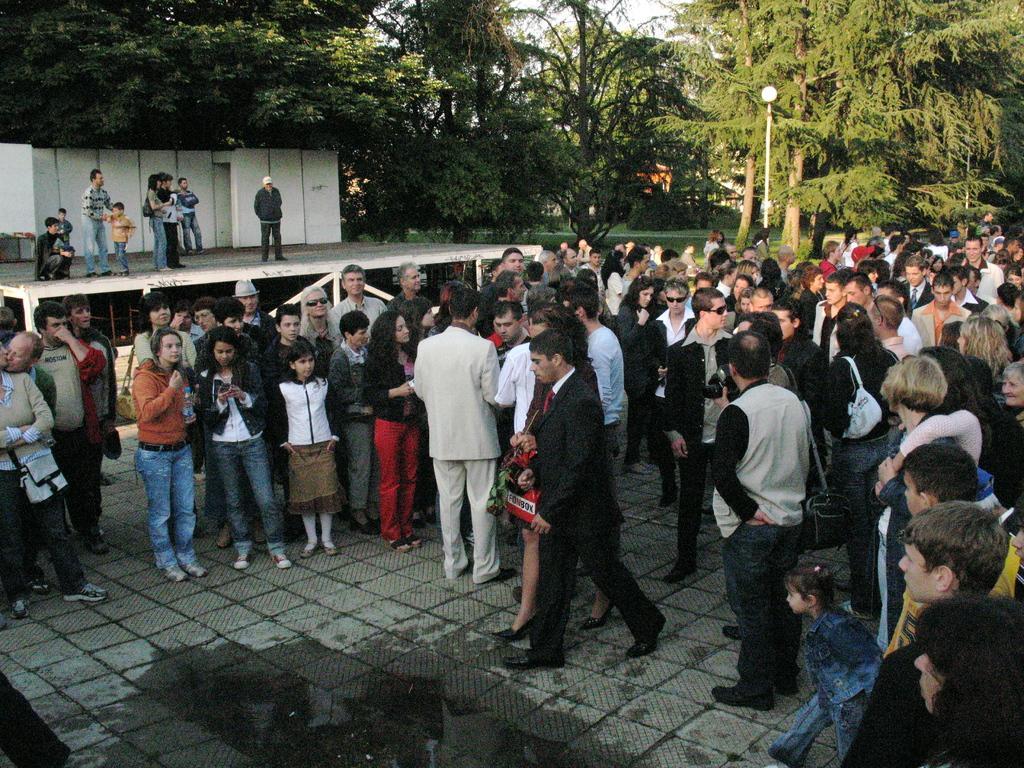How would you summarize this image in a sentence or two? In the center of the image there are group of persons standing on the floor. In the background there are persons, trees, street light, grass and sky. 